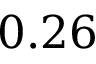Convert formula to latex. <formula><loc_0><loc_0><loc_500><loc_500>0 . 2 6</formula> 